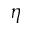Convert formula to latex. <formula><loc_0><loc_0><loc_500><loc_500>\eta</formula> 